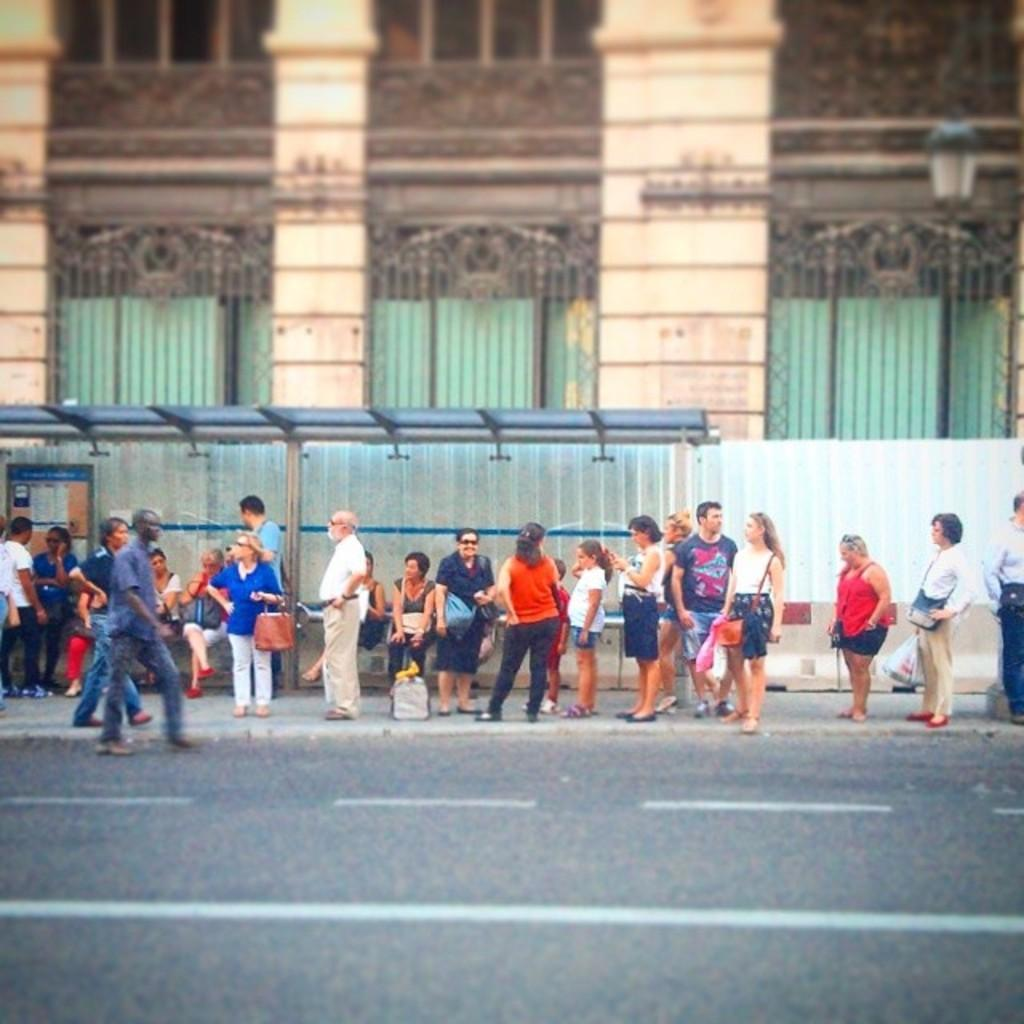How many people are in the image? There are many persons sitting and standing in the image. Where are the persons located in the image? The persons are on the roads. What is at the bottom of the image? There is a road at the bottom of the image. What can be seen in the background of the image? There are buildings and a light pole in the background of the image. Can you see a kite flying in the image? There is no kite present in the image. What do you believe about the persons' intentions in the image? The image does not provide any information about the persons' intentions, so it cannot be determined from the image. 